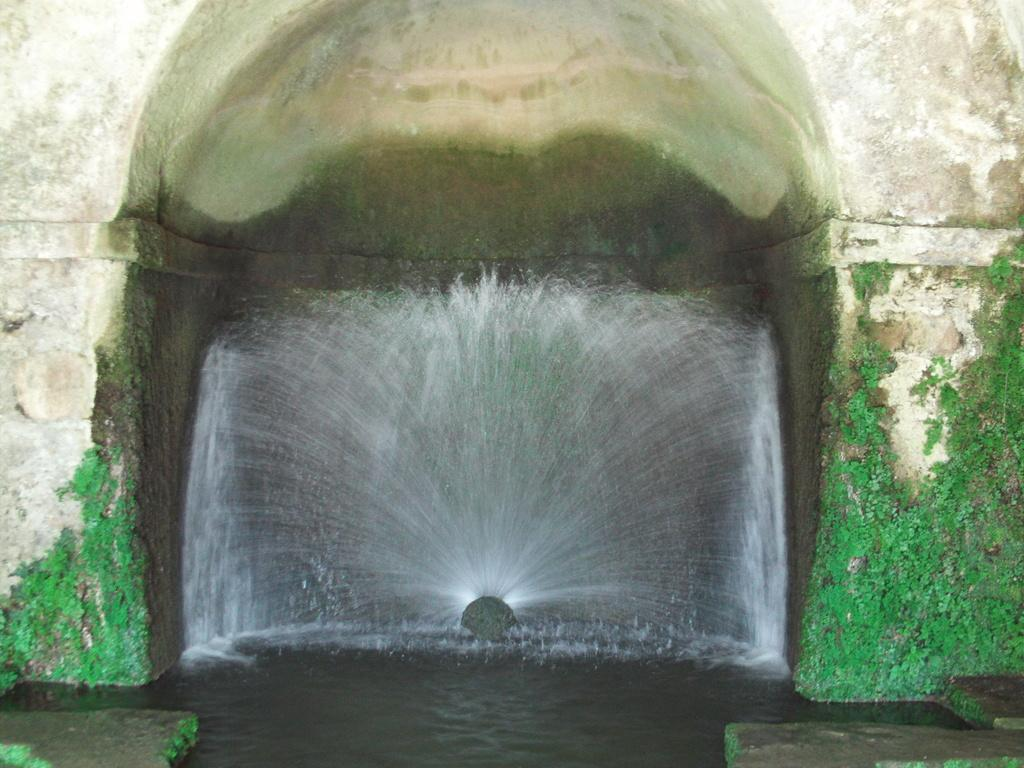What type of structure can be seen in the image? There is an arch-shaped wall in the image. What is located near the wall? There is a fountain near the wall. What is the fountain doing? Water is sprinkling from the fountain. What is growing on the wall? Green algae is present on the wall. Can you see any wounds on the wall in the image? There are no wounds visible on the wall in the image. Is there any poison present in the image? There is no mention of poison in the image. 